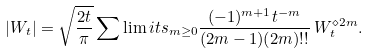Convert formula to latex. <formula><loc_0><loc_0><loc_500><loc_500>| W _ { t } | = \sqrt { \frac { 2 t } { \pi } } \sum \lim i t s _ { m \geq 0 } \frac { ( - 1 ) ^ { m + 1 } t ^ { - m } } { ( 2 m - 1 ) ( 2 m ) ! ! } \, W _ { t } ^ { \diamond 2 m } .</formula> 